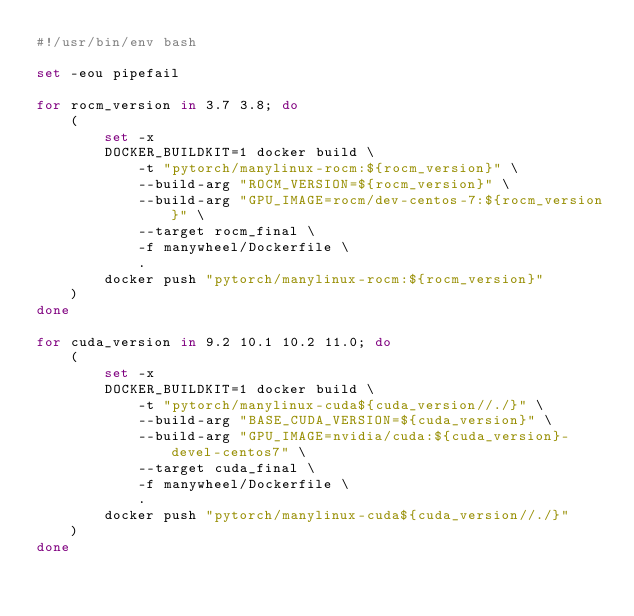<code> <loc_0><loc_0><loc_500><loc_500><_Bash_>#!/usr/bin/env bash

set -eou pipefail

for rocm_version in 3.7 3.8; do
    (
        set -x
        DOCKER_BUILDKIT=1 docker build \
            -t "pytorch/manylinux-rocm:${rocm_version}" \
            --build-arg "ROCM_VERSION=${rocm_version}" \
            --build-arg "GPU_IMAGE=rocm/dev-centos-7:${rocm_version}" \
            --target rocm_final \
            -f manywheel/Dockerfile \
            .
        docker push "pytorch/manylinux-rocm:${rocm_version}"
    )
done

for cuda_version in 9.2 10.1 10.2 11.0; do
    (
        set -x
        DOCKER_BUILDKIT=1 docker build \
            -t "pytorch/manylinux-cuda${cuda_version//./}" \
            --build-arg "BASE_CUDA_VERSION=${cuda_version}" \
            --build-arg "GPU_IMAGE=nvidia/cuda:${cuda_version}-devel-centos7" \
            --target cuda_final \
            -f manywheel/Dockerfile \
            .
        docker push "pytorch/manylinux-cuda${cuda_version//./}"
    )
done
</code> 